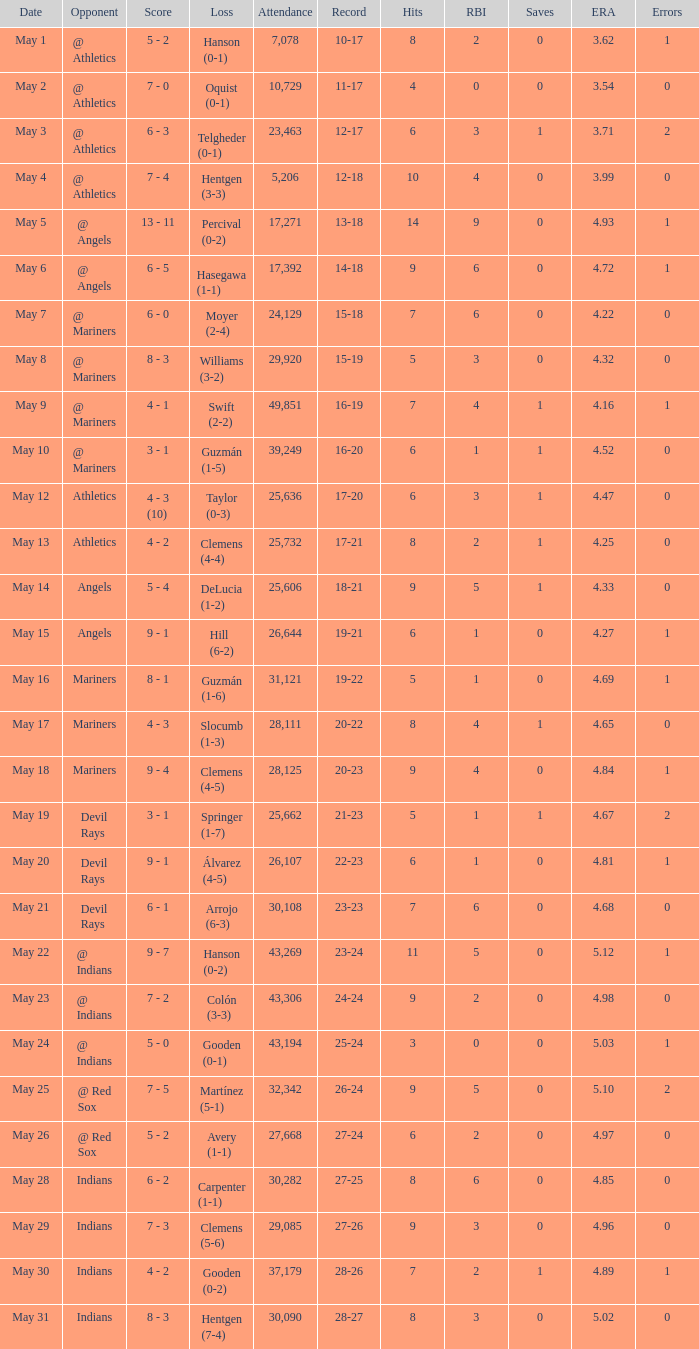Could you parse the entire table as a dict? {'header': ['Date', 'Opponent', 'Score', 'Loss', 'Attendance', 'Record', 'Hits', 'RBI', 'Saves', 'ERA', 'Errors'], 'rows': [['May 1', '@ Athletics', '5 - 2', 'Hanson (0-1)', '7,078', '10-17', '8', '2', '0', '3.62', '1'], ['May 2', '@ Athletics', '7 - 0', 'Oquist (0-1)', '10,729', '11-17', '4', '0', '0', '3.54', '0'], ['May 3', '@ Athletics', '6 - 3', 'Telgheder (0-1)', '23,463', '12-17', '6', '3', '1', '3.71', '2'], ['May 4', '@ Athletics', '7 - 4', 'Hentgen (3-3)', '5,206', '12-18', '10', '4', '0', '3.99', '0'], ['May 5', '@ Angels', '13 - 11', 'Percival (0-2)', '17,271', '13-18', '14', '9', '0', '4.93', '1'], ['May 6', '@ Angels', '6 - 5', 'Hasegawa (1-1)', '17,392', '14-18', '9', '6', '0', '4.72', '1'], ['May 7', '@ Mariners', '6 - 0', 'Moyer (2-4)', '24,129', '15-18', '7', '6', '0', '4.22', '0'], ['May 8', '@ Mariners', '8 - 3', 'Williams (3-2)', '29,920', '15-19', '5', '3', '0', '4.32', '0'], ['May 9', '@ Mariners', '4 - 1', 'Swift (2-2)', '49,851', '16-19', '7', '4', '1', '4.16', '1'], ['May 10', '@ Mariners', '3 - 1', 'Guzmán (1-5)', '39,249', '16-20', '6', '1', '1', '4.52', '0'], ['May 12', 'Athletics', '4 - 3 (10)', 'Taylor (0-3)', '25,636', '17-20', '6', '3', '1', '4.47', '0'], ['May 13', 'Athletics', '4 - 2', 'Clemens (4-4)', '25,732', '17-21', '8', '2', '1', '4.25', '0'], ['May 14', 'Angels', '5 - 4', 'DeLucia (1-2)', '25,606', '18-21', '9', '5', '1', '4.33', '0'], ['May 15', 'Angels', '9 - 1', 'Hill (6-2)', '26,644', '19-21', '6', '1', '0', '4.27', '1'], ['May 16', 'Mariners', '8 - 1', 'Guzmán (1-6)', '31,121', '19-22', '5', '1', '0', '4.69', '1'], ['May 17', 'Mariners', '4 - 3', 'Slocumb (1-3)', '28,111', '20-22', '8', '4', '1', '4.65', '0'], ['May 18', 'Mariners', '9 - 4', 'Clemens (4-5)', '28,125', '20-23', '9', '4', '0', '4.84', '1'], ['May 19', 'Devil Rays', '3 - 1', 'Springer (1-7)', '25,662', '21-23', '5', '1', '1', '4.67', '2'], ['May 20', 'Devil Rays', '9 - 1', 'Álvarez (4-5)', '26,107', '22-23', '6', '1', '0', '4.81', '1'], ['May 21', 'Devil Rays', '6 - 1', 'Arrojo (6-3)', '30,108', '23-23', '7', '6', '0', '4.68', '0'], ['May 22', '@ Indians', '9 - 7', 'Hanson (0-2)', '43,269', '23-24', '11', '5', '0', '5.12', '1'], ['May 23', '@ Indians', '7 - 2', 'Colón (3-3)', '43,306', '24-24', '9', '2', '0', '4.98', '0'], ['May 24', '@ Indians', '5 - 0', 'Gooden (0-1)', '43,194', '25-24', '3', '0', '0', '5.03', '1'], ['May 25', '@ Red Sox', '7 - 5', 'Martínez (5-1)', '32,342', '26-24', '9', '5', '0', '5.10', '2'], ['May 26', '@ Red Sox', '5 - 2', 'Avery (1-1)', '27,668', '27-24', '6', '2', '0', '4.97', '0'], ['May 28', 'Indians', '6 - 2', 'Carpenter (1-1)', '30,282', '27-25', '8', '6', '0', '4.85', '0'], ['May 29', 'Indians', '7 - 3', 'Clemens (5-6)', '29,085', '27-26', '9', '3', '0', '4.96', '0'], ['May 30', 'Indians', '4 - 2', 'Gooden (0-2)', '37,179', '28-26', '7', '2', '1', '4.89', '1'], ['May 31', 'Indians', '8 - 3', 'Hentgen (7-4)', '30,090', '28-27', '8', '3', '0', '5.02', '0']]} When was the score 27-25? May 28. 